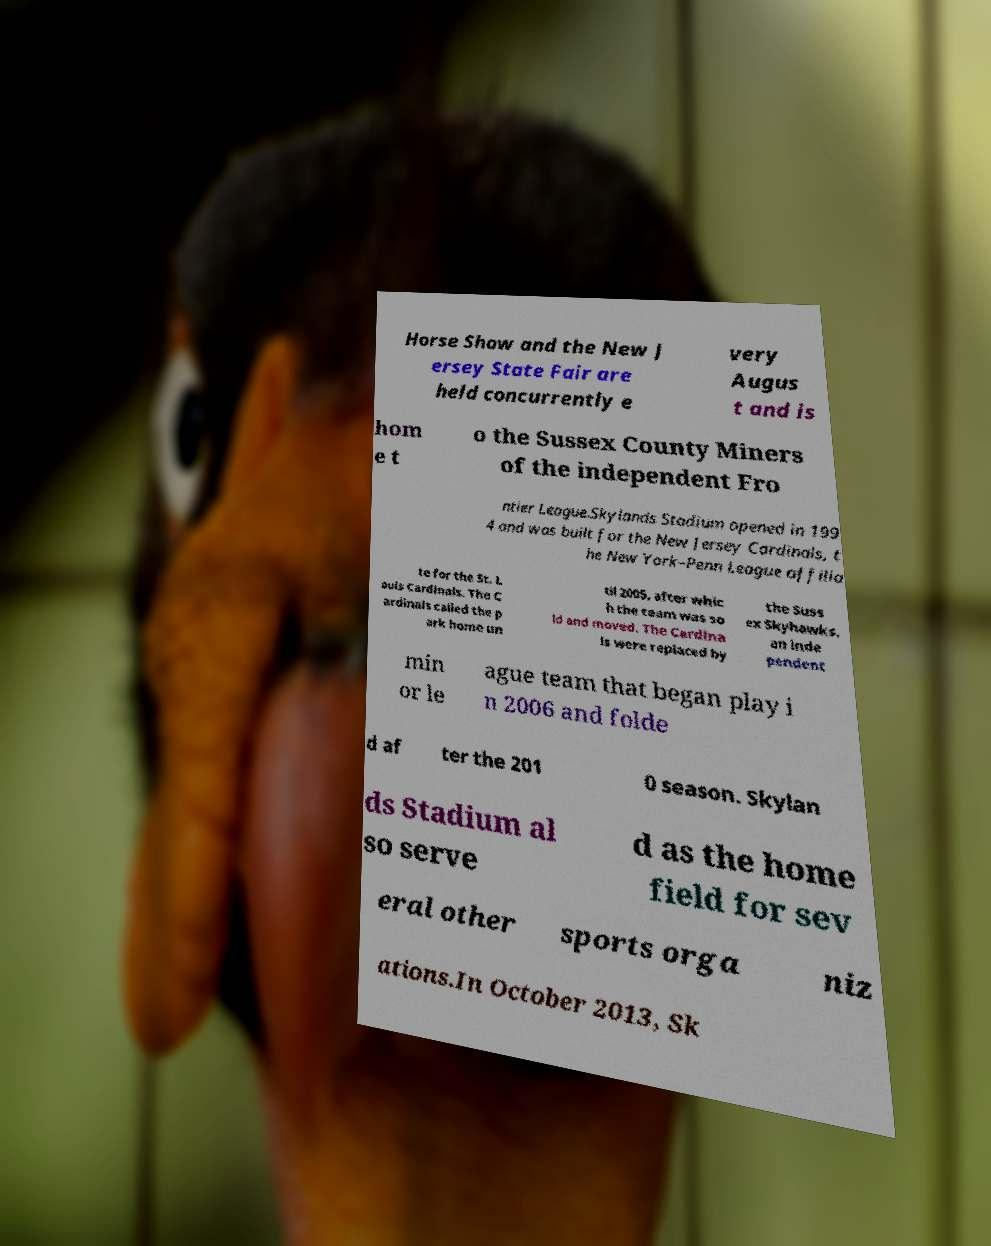Could you assist in decoding the text presented in this image and type it out clearly? Horse Show and the New J ersey State Fair are held concurrently e very Augus t and is hom e t o the Sussex County Miners of the independent Fro ntier League.Skylands Stadium opened in 199 4 and was built for the New Jersey Cardinals, t he New York–Penn League affilia te for the St. L ouis Cardinals. The C ardinals called the p ark home un til 2005, after whic h the team was so ld and moved. The Cardina ls were replaced by the Suss ex Skyhawks, an inde pendent min or le ague team that began play i n 2006 and folde d af ter the 201 0 season. Skylan ds Stadium al so serve d as the home field for sev eral other sports orga niz ations.In October 2013, Sk 